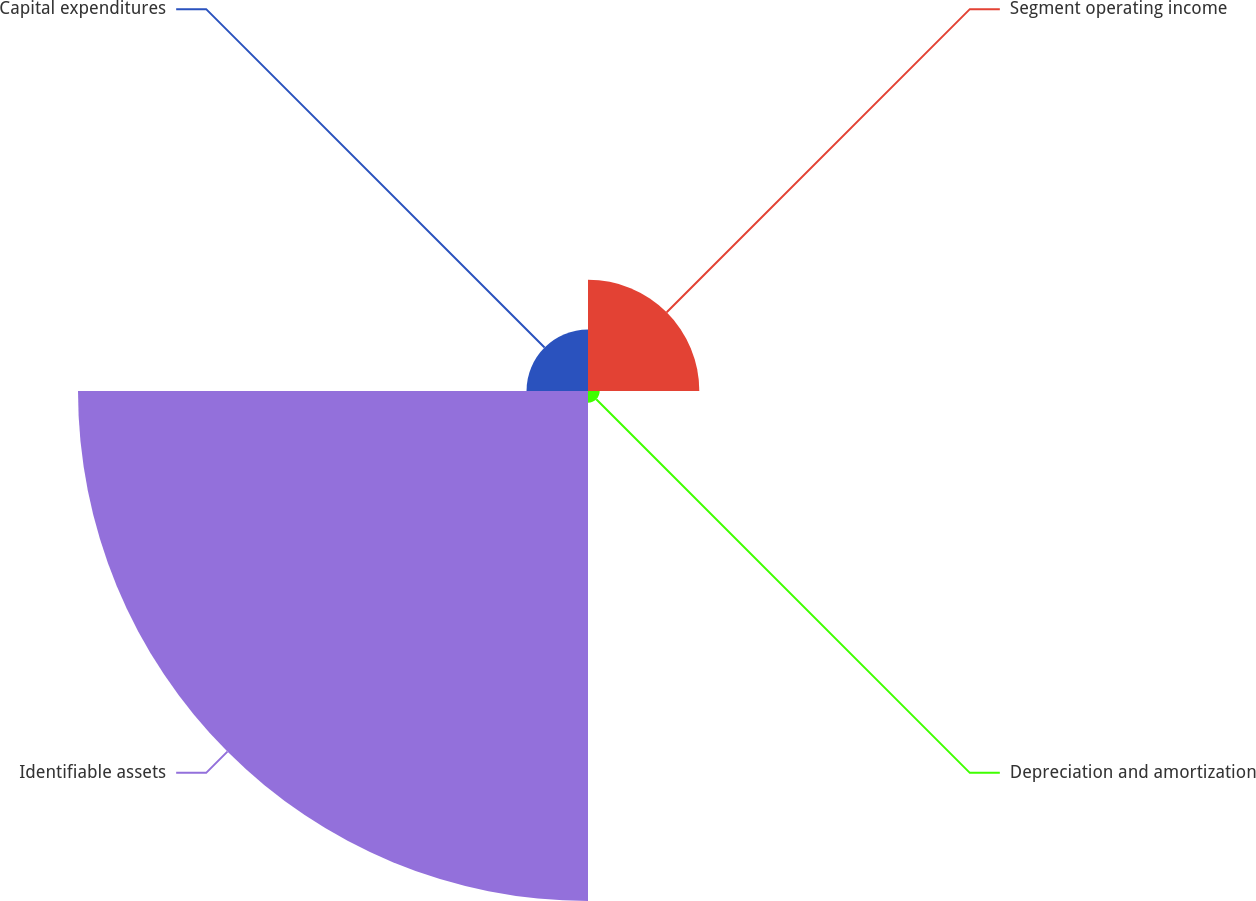Convert chart to OTSL. <chart><loc_0><loc_0><loc_500><loc_500><pie_chart><fcel>Segment operating income<fcel>Depreciation and amortization<fcel>Identifiable assets<fcel>Capital expenditures<nl><fcel>16.03%<fcel>1.68%<fcel>73.44%<fcel>8.85%<nl></chart> 